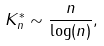<formula> <loc_0><loc_0><loc_500><loc_500>K _ { n } ^ { * } \sim \frac { n } { \log ( n ) } ,</formula> 